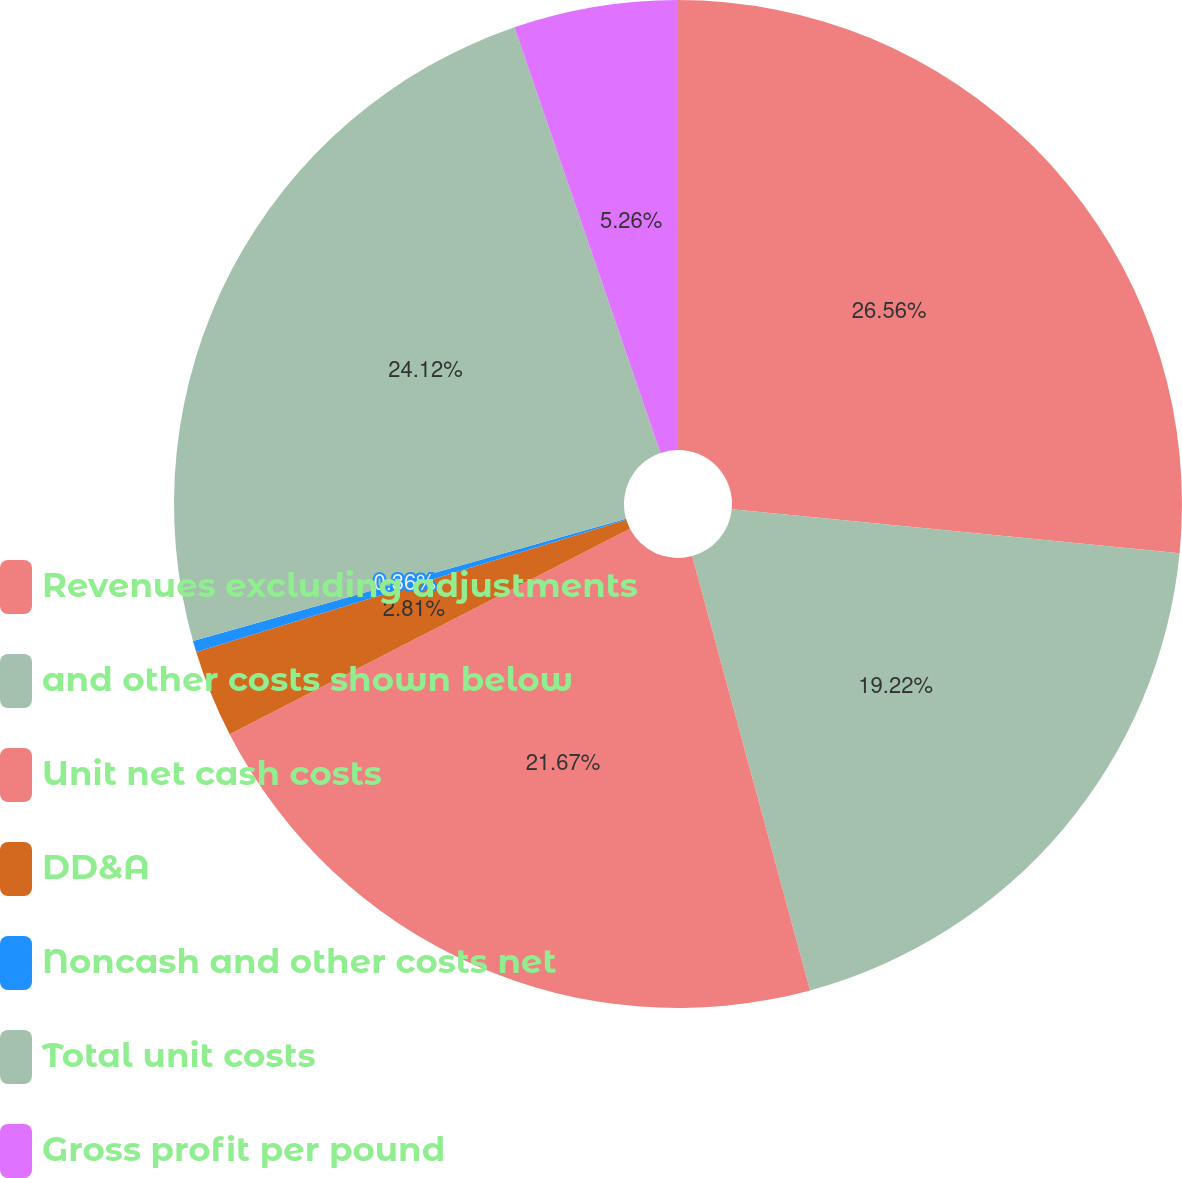<chart> <loc_0><loc_0><loc_500><loc_500><pie_chart><fcel>Revenues excluding adjustments<fcel>and other costs shown below<fcel>Unit net cash costs<fcel>DD&A<fcel>Noncash and other costs net<fcel>Total unit costs<fcel>Gross profit per pound<nl><fcel>26.56%<fcel>19.22%<fcel>21.67%<fcel>2.81%<fcel>0.36%<fcel>24.12%<fcel>5.26%<nl></chart> 